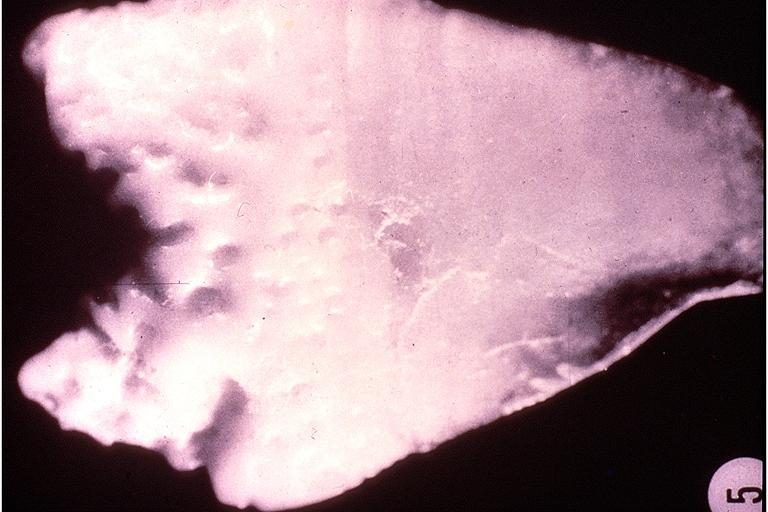does this image show turners tooth?
Answer the question using a single word or phrase. Yes 